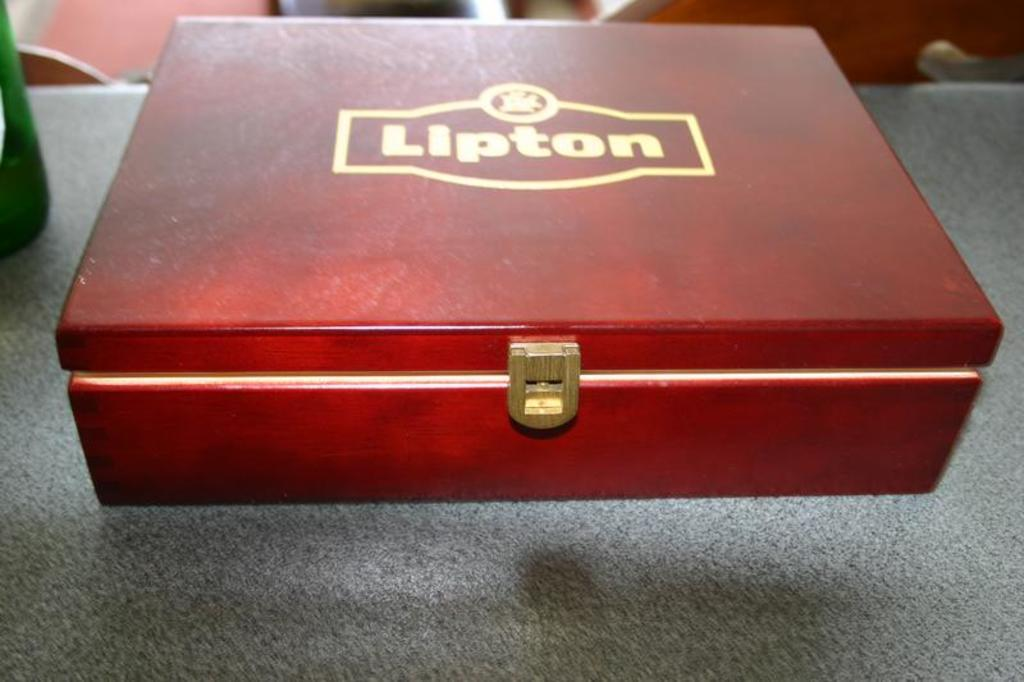<image>
Share a concise interpretation of the image provided. a red wooden box with gold lettering on it that says 'lipton' 